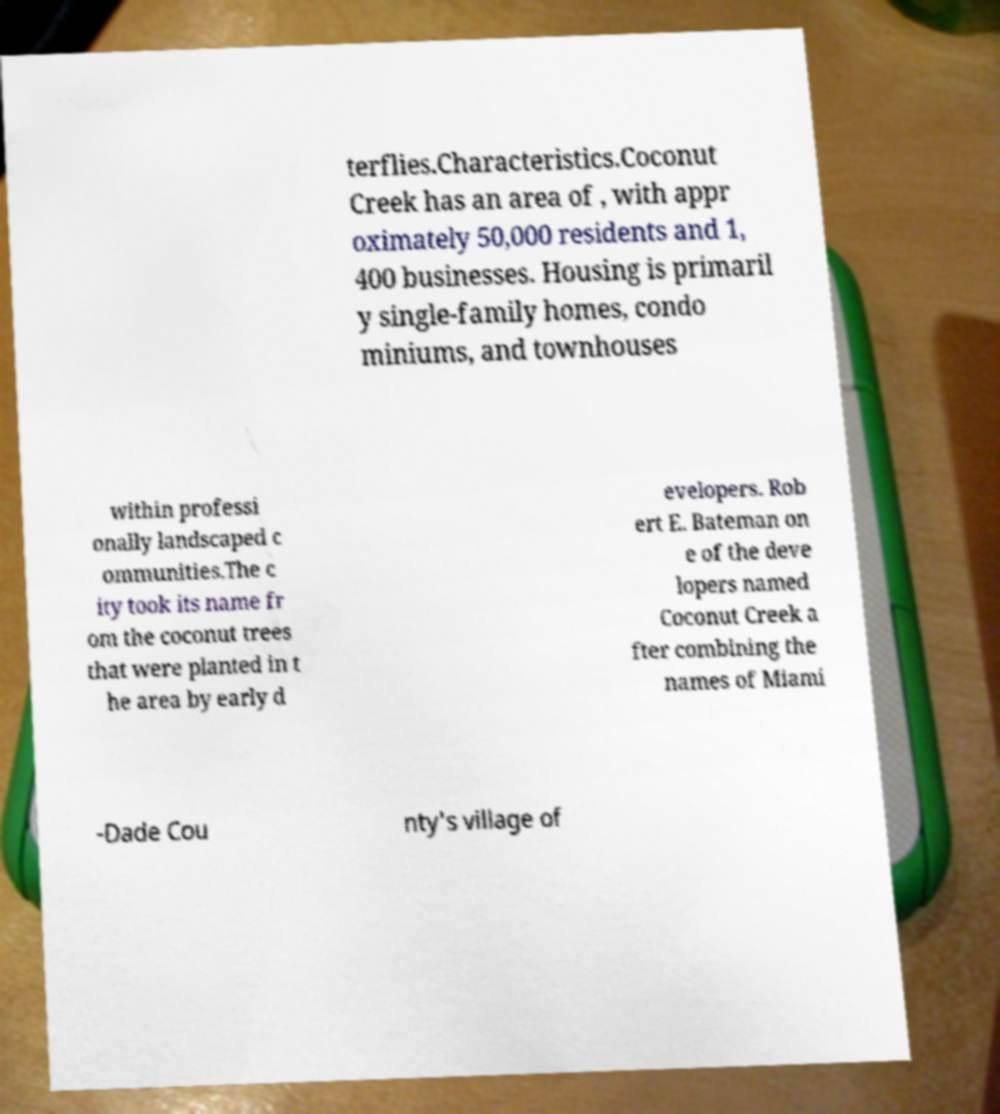For documentation purposes, I need the text within this image transcribed. Could you provide that? terflies.Characteristics.Coconut Creek has an area of , with appr oximately 50,000 residents and 1, 400 businesses. Housing is primaril y single-family homes, condo miniums, and townhouses within professi onally landscaped c ommunities.The c ity took its name fr om the coconut trees that were planted in t he area by early d evelopers. Rob ert E. Bateman on e of the deve lopers named Coconut Creek a fter combining the names of Miami -Dade Cou nty's village of 